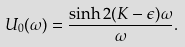Convert formula to latex. <formula><loc_0><loc_0><loc_500><loc_500>U _ { 0 } ( \omega ) = \frac { \sinh 2 ( K - \epsilon ) \omega } { \omega } .</formula> 